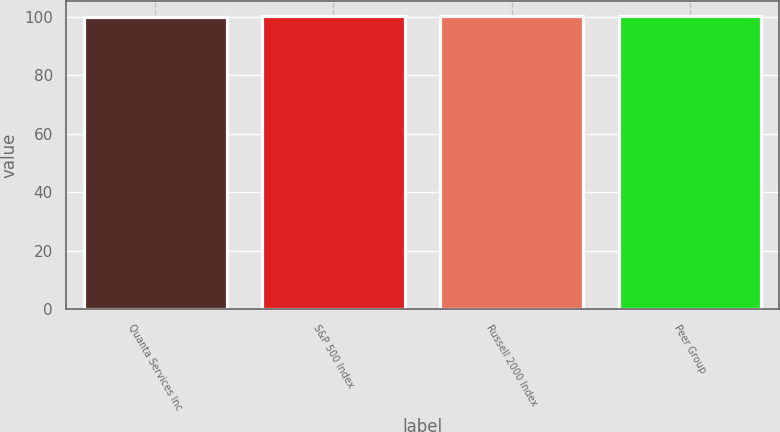<chart> <loc_0><loc_0><loc_500><loc_500><bar_chart><fcel>Quanta Services Inc<fcel>S&P 500 Index<fcel>Russell 2000 Index<fcel>Peer Group<nl><fcel>100<fcel>100.1<fcel>100.2<fcel>100.3<nl></chart> 